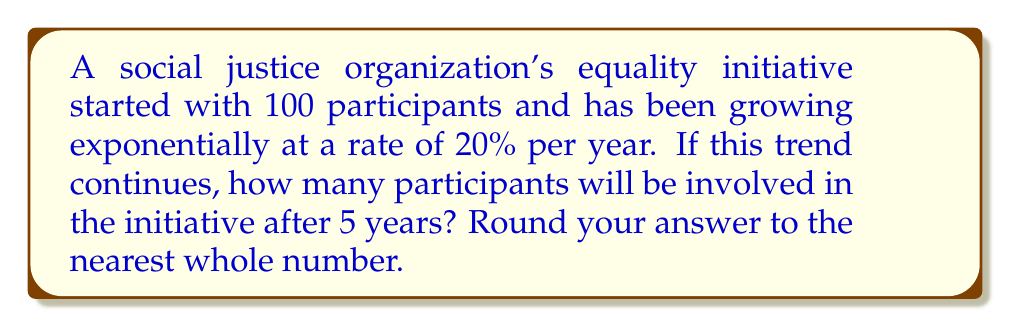Help me with this question. Let's approach this step-by-step:

1) The initial number of participants is 100.
2) The growth rate is 20% per year, which means the multiplier is 1.20 (100% + 20% = 120% = 1.20).
3) We need to calculate this over 5 years.

We can use the exponential growth formula:

$$A = P(1 + r)^t$$

Where:
$A$ = Final amount
$P$ = Initial principal balance
$r$ = Annual growth rate (in decimal form)
$t$ = Number of years

Plugging in our values:

$$A = 100(1 + 0.20)^5$$

$$A = 100(1.20)^5$$

Now, let's calculate:

$$A = 100 * 2.4883$$

$$A = 248.83$$

Rounding to the nearest whole number:

$$A ≈ 249$$
Answer: 249 participants 